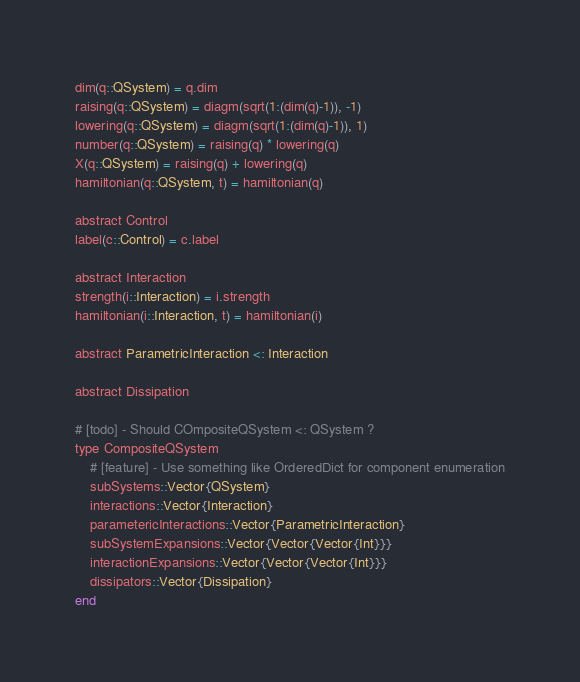<code> <loc_0><loc_0><loc_500><loc_500><_Julia_>dim(q::QSystem) = q.dim
raising(q::QSystem) = diagm(sqrt(1:(dim(q)-1)), -1)
lowering(q::QSystem) = diagm(sqrt(1:(dim(q)-1)), 1)
number(q::QSystem) = raising(q) * lowering(q)
X(q::QSystem) = raising(q) + lowering(q)
hamiltonian(q::QSystem, t) = hamiltonian(q)

abstract Control
label(c::Control) = c.label

abstract Interaction
strength(i::Interaction) = i.strength
hamiltonian(i::Interaction, t) = hamiltonian(i)

abstract ParametricInteraction <: Interaction

abstract Dissipation

# [todo] - Should COmpositeQSystem <: QSystem ? 
type CompositeQSystem
    # [feature] - Use something like OrderedDict for component enumeration
    subSystems::Vector{QSystem}
    interactions::Vector{Interaction}
    parametericInteractions::Vector{ParametricInteraction}
    subSystemExpansions::Vector{Vector{Vector{Int}}}
    interactionExpansions::Vector{Vector{Vector{Int}}}
    dissipators::Vector{Dissipation}
end


</code> 